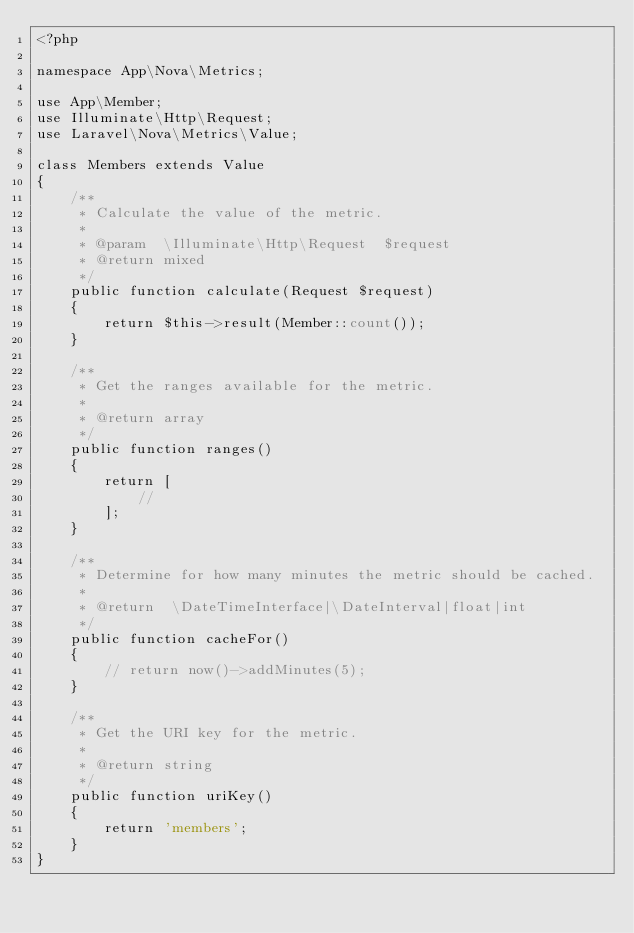Convert code to text. <code><loc_0><loc_0><loc_500><loc_500><_PHP_><?php

namespace App\Nova\Metrics;

use App\Member;
use Illuminate\Http\Request;
use Laravel\Nova\Metrics\Value;

class Members extends Value
{
    /**
     * Calculate the value of the metric.
     *
     * @param  \Illuminate\Http\Request  $request
     * @return mixed
     */
    public function calculate(Request $request)
    {
        return $this->result(Member::count());
    }

    /**
     * Get the ranges available for the metric.
     *
     * @return array
     */
    public function ranges()
    {
        return [
            //
        ];
    }

    /**
     * Determine for how many minutes the metric should be cached.
     *
     * @return  \DateTimeInterface|\DateInterval|float|int
     */
    public function cacheFor()
    {
        // return now()->addMinutes(5);
    }

    /**
     * Get the URI key for the metric.
     *
     * @return string
     */
    public function uriKey()
    {
        return 'members';
    }
}
</code> 